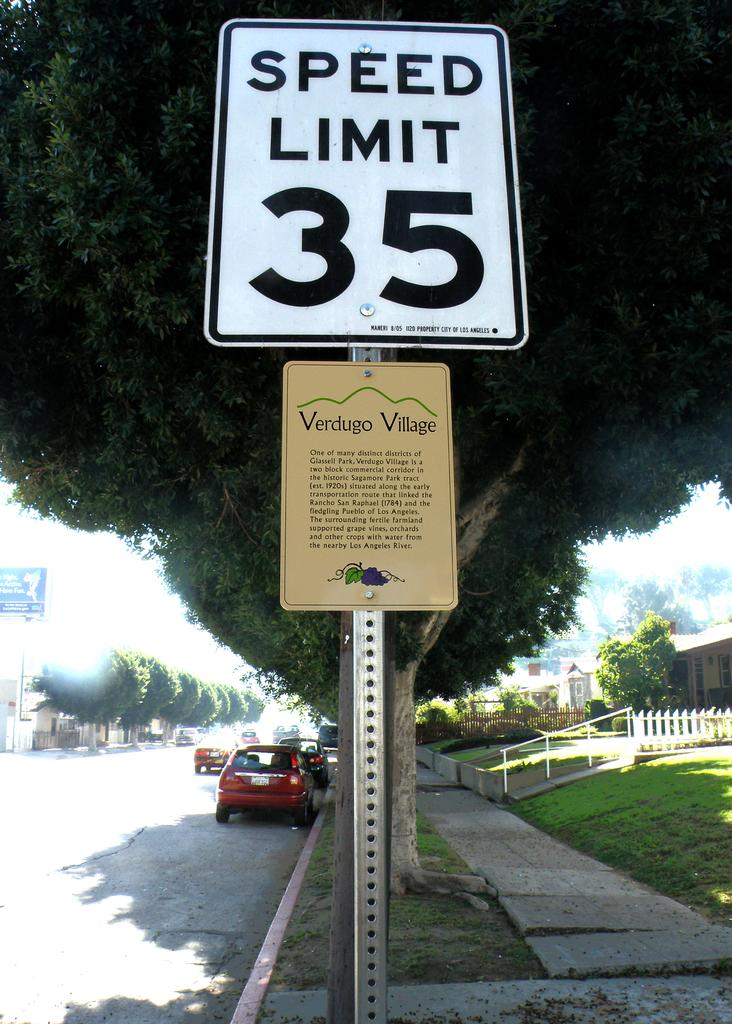Provide a one-sentence caption for the provided image. A sign that says Speed Limit 35 is on the side of a street lined with parked cars. 